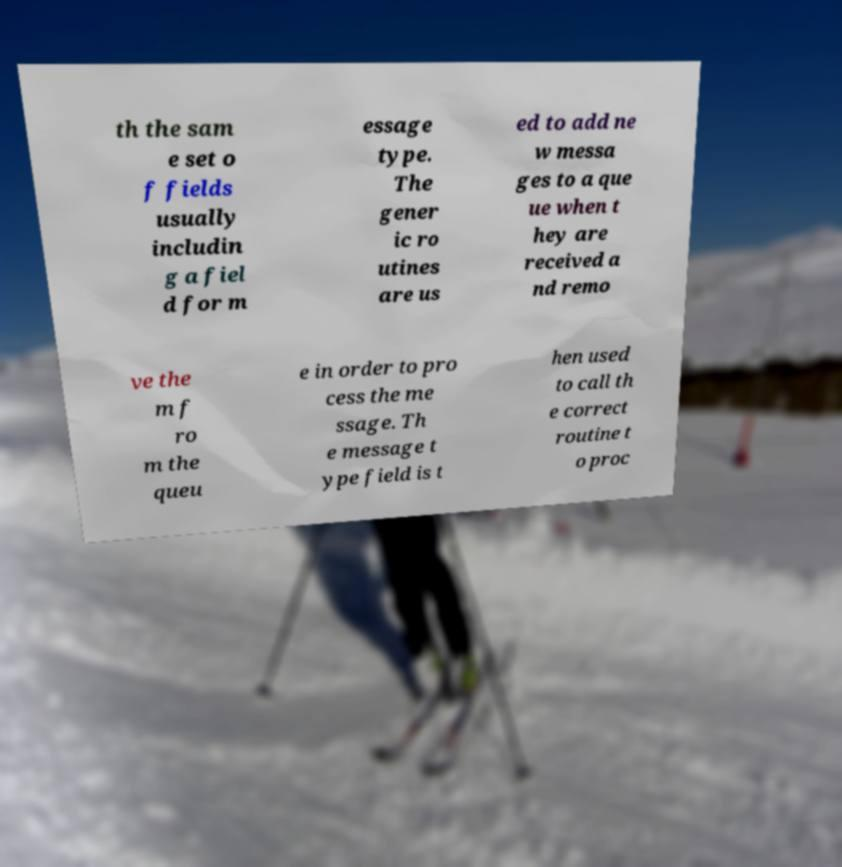What messages or text are displayed in this image? I need them in a readable, typed format. th the sam e set o f fields usually includin g a fiel d for m essage type. The gener ic ro utines are us ed to add ne w messa ges to a que ue when t hey are received a nd remo ve the m f ro m the queu e in order to pro cess the me ssage. Th e message t ype field is t hen used to call th e correct routine t o proc 